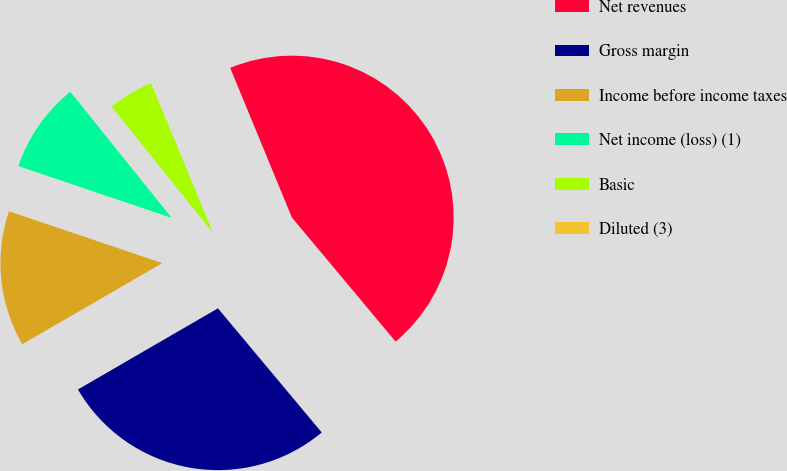<chart> <loc_0><loc_0><loc_500><loc_500><pie_chart><fcel>Net revenues<fcel>Gross margin<fcel>Income before income taxes<fcel>Net income (loss) (1)<fcel>Basic<fcel>Diluted (3)<nl><fcel>45.14%<fcel>27.72%<fcel>13.55%<fcel>9.04%<fcel>4.53%<fcel>0.02%<nl></chart> 